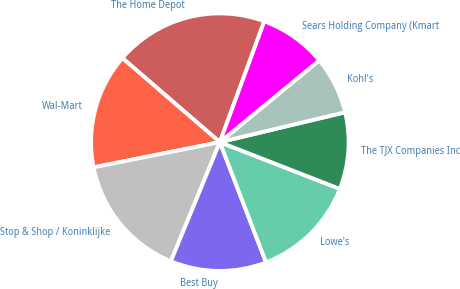<chart> <loc_0><loc_0><loc_500><loc_500><pie_chart><fcel>The Home Depot<fcel>Wal-Mart<fcel>Stop & Shop / Koninklijke<fcel>Best Buy<fcel>Lowe's<fcel>The TJX Companies Inc<fcel>Kohl's<fcel>Sears Holding Company (Kmart<nl><fcel>19.28%<fcel>14.46%<fcel>15.66%<fcel>12.05%<fcel>13.25%<fcel>9.64%<fcel>7.23%<fcel>8.43%<nl></chart> 